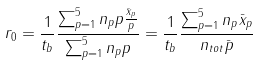Convert formula to latex. <formula><loc_0><loc_0><loc_500><loc_500>r _ { 0 } = \frac { 1 } { t _ { b } } \frac { \sum _ { p = 1 } ^ { 5 } n _ { p } p \frac { \bar { x } _ { p } } { p } } { \sum _ { p = 1 } ^ { 5 } n _ { p } p } = \frac { 1 } { t _ { b } } \frac { \sum _ { p = 1 } ^ { 5 } n _ { p } \bar { x } _ { p } } { n _ { t o t } \bar { p } }</formula> 